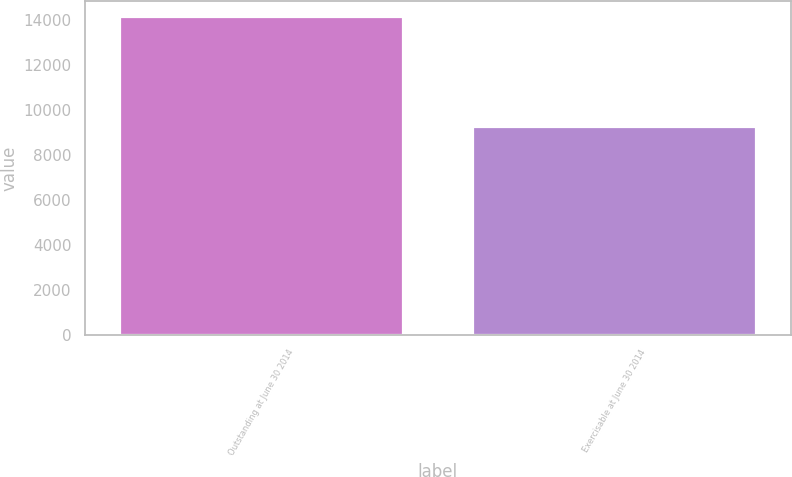Convert chart. <chart><loc_0><loc_0><loc_500><loc_500><bar_chart><fcel>Outstanding at June 30 2014<fcel>Exercisable at June 30 2014<nl><fcel>14127.8<fcel>9248.2<nl></chart> 